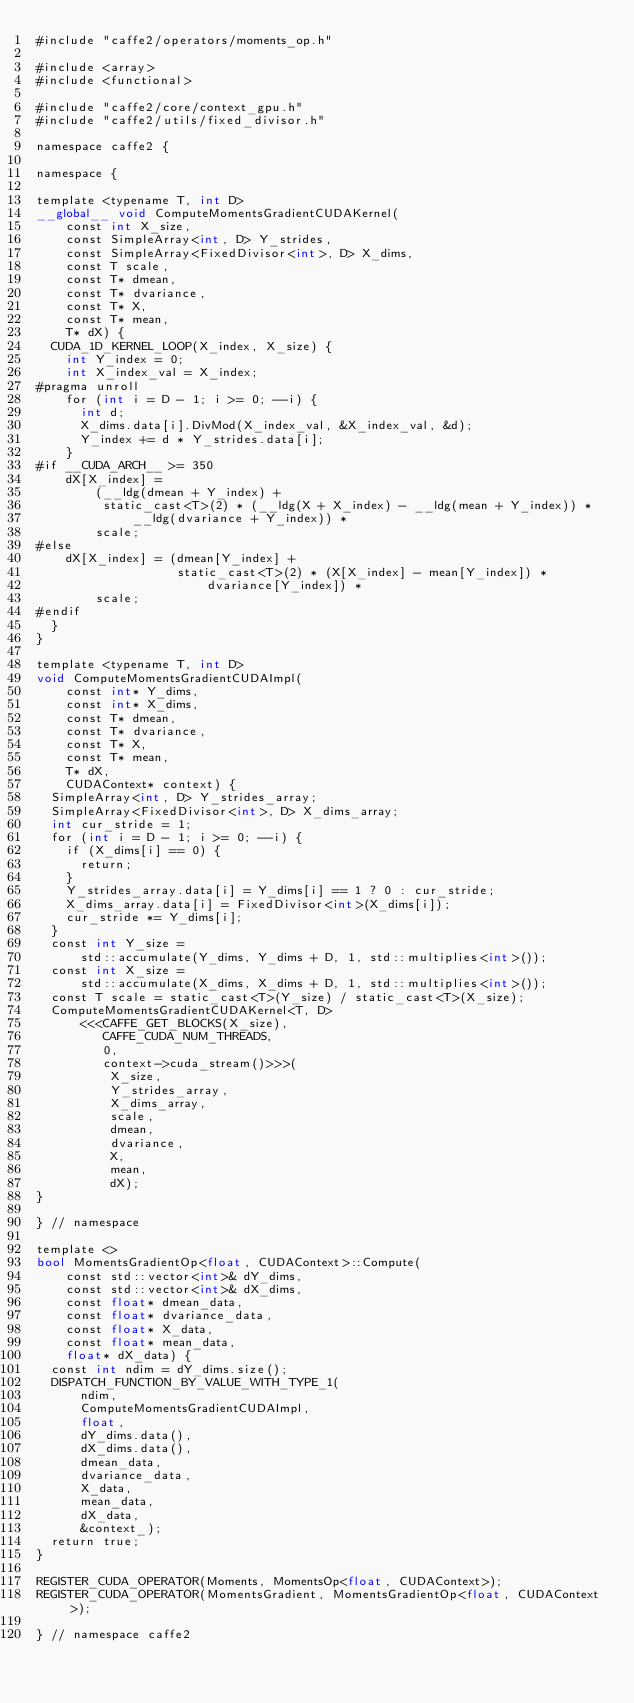Convert code to text. <code><loc_0><loc_0><loc_500><loc_500><_Cuda_>#include "caffe2/operators/moments_op.h"

#include <array>
#include <functional>

#include "caffe2/core/context_gpu.h"
#include "caffe2/utils/fixed_divisor.h"

namespace caffe2 {

namespace {

template <typename T, int D>
__global__ void ComputeMomentsGradientCUDAKernel(
    const int X_size,
    const SimpleArray<int, D> Y_strides,
    const SimpleArray<FixedDivisor<int>, D> X_dims,
    const T scale,
    const T* dmean,
    const T* dvariance,
    const T* X,
    const T* mean,
    T* dX) {
  CUDA_1D_KERNEL_LOOP(X_index, X_size) {
    int Y_index = 0;
    int X_index_val = X_index;
#pragma unroll
    for (int i = D - 1; i >= 0; --i) {
      int d;
      X_dims.data[i].DivMod(X_index_val, &X_index_val, &d);
      Y_index += d * Y_strides.data[i];
    }
#if __CUDA_ARCH__ >= 350
    dX[X_index] =
        (__ldg(dmean + Y_index) +
         static_cast<T>(2) * (__ldg(X + X_index) - __ldg(mean + Y_index)) *
             __ldg(dvariance + Y_index)) *
        scale;
#else
    dX[X_index] = (dmean[Y_index] +
                   static_cast<T>(2) * (X[X_index] - mean[Y_index]) *
                       dvariance[Y_index]) *
        scale;
#endif
  }
}

template <typename T, int D>
void ComputeMomentsGradientCUDAImpl(
    const int* Y_dims,
    const int* X_dims,
    const T* dmean,
    const T* dvariance,
    const T* X,
    const T* mean,
    T* dX,
    CUDAContext* context) {
  SimpleArray<int, D> Y_strides_array;
  SimpleArray<FixedDivisor<int>, D> X_dims_array;
  int cur_stride = 1;
  for (int i = D - 1; i >= 0; --i) {
    if (X_dims[i] == 0) {
      return;
    }
    Y_strides_array.data[i] = Y_dims[i] == 1 ? 0 : cur_stride;
    X_dims_array.data[i] = FixedDivisor<int>(X_dims[i]);
    cur_stride *= Y_dims[i];
  }
  const int Y_size =
      std::accumulate(Y_dims, Y_dims + D, 1, std::multiplies<int>());
  const int X_size =
      std::accumulate(X_dims, X_dims + D, 1, std::multiplies<int>());
  const T scale = static_cast<T>(Y_size) / static_cast<T>(X_size);
  ComputeMomentsGradientCUDAKernel<T, D>
      <<<CAFFE_GET_BLOCKS(X_size),
         CAFFE_CUDA_NUM_THREADS,
         0,
         context->cuda_stream()>>>(
          X_size,
          Y_strides_array,
          X_dims_array,
          scale,
          dmean,
          dvariance,
          X,
          mean,
          dX);
}

} // namespace

template <>
bool MomentsGradientOp<float, CUDAContext>::Compute(
    const std::vector<int>& dY_dims,
    const std::vector<int>& dX_dims,
    const float* dmean_data,
    const float* dvariance_data,
    const float* X_data,
    const float* mean_data,
    float* dX_data) {
  const int ndim = dY_dims.size();
  DISPATCH_FUNCTION_BY_VALUE_WITH_TYPE_1(
      ndim,
      ComputeMomentsGradientCUDAImpl,
      float,
      dY_dims.data(),
      dX_dims.data(),
      dmean_data,
      dvariance_data,
      X_data,
      mean_data,
      dX_data,
      &context_);
  return true;
}

REGISTER_CUDA_OPERATOR(Moments, MomentsOp<float, CUDAContext>);
REGISTER_CUDA_OPERATOR(MomentsGradient, MomentsGradientOp<float, CUDAContext>);

} // namespace caffe2
</code> 